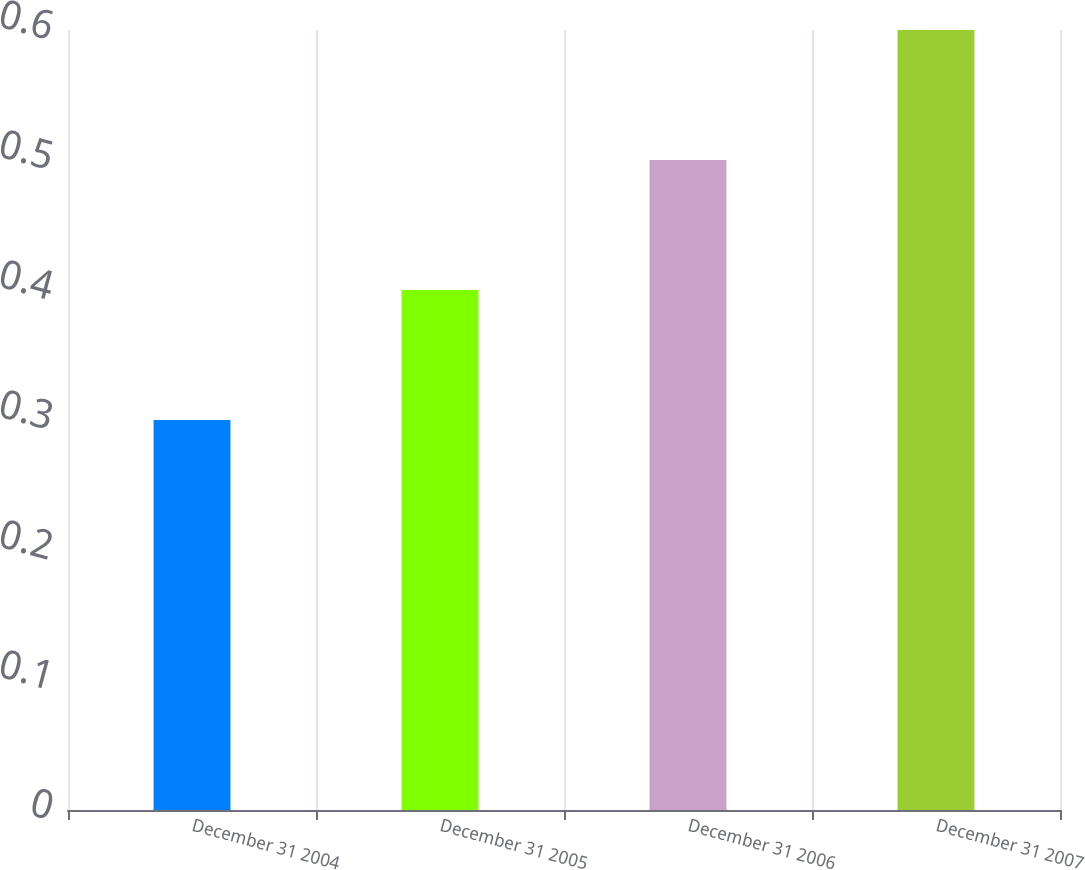Convert chart to OTSL. <chart><loc_0><loc_0><loc_500><loc_500><bar_chart><fcel>December 31 2004<fcel>December 31 2005<fcel>December 31 2006<fcel>December 31 2007<nl><fcel>0.3<fcel>0.4<fcel>0.5<fcel>0.6<nl></chart> 